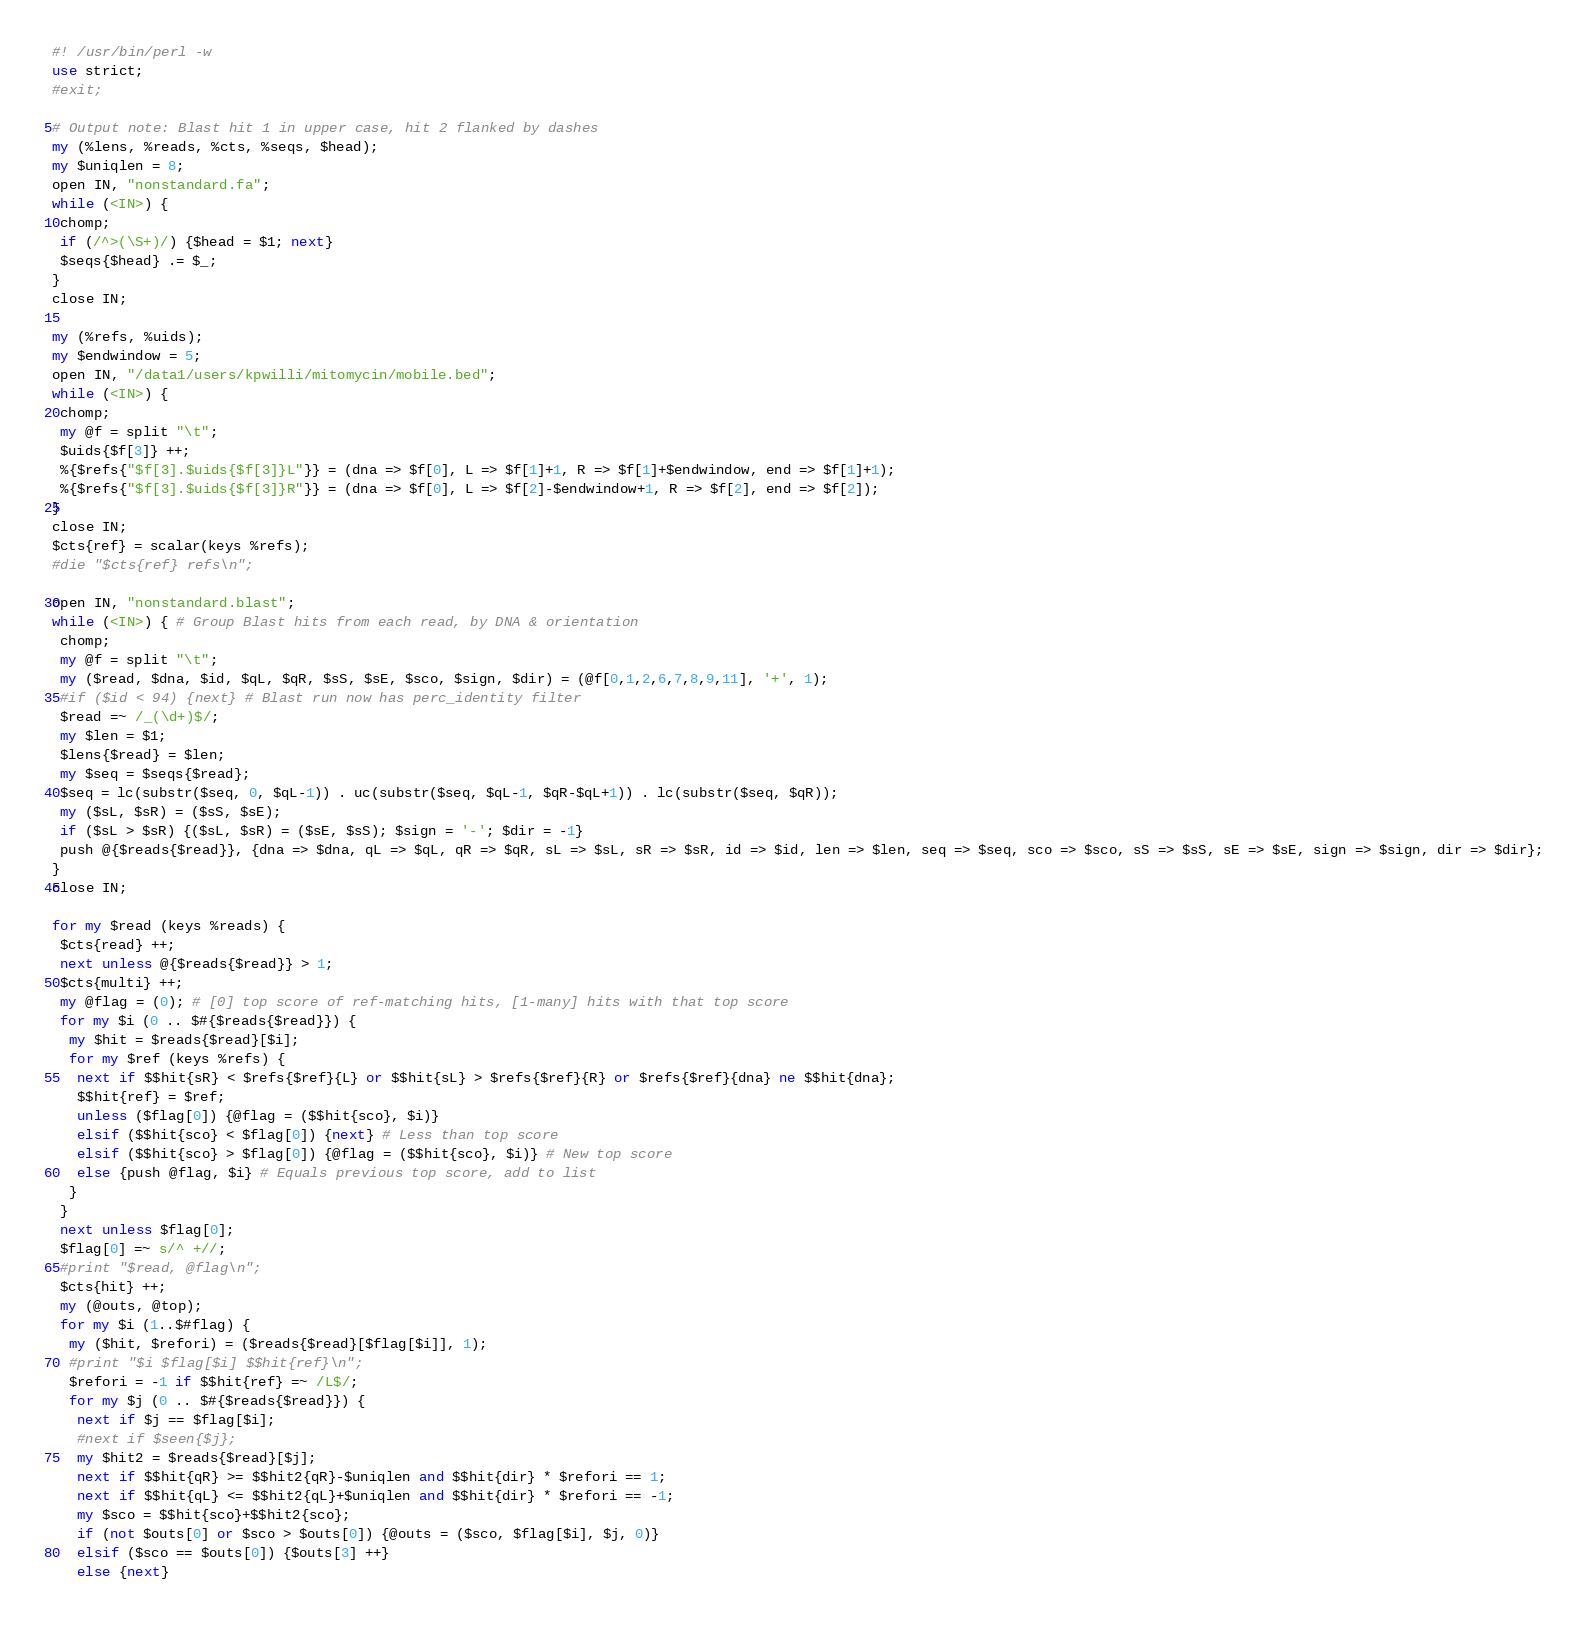Convert code to text. <code><loc_0><loc_0><loc_500><loc_500><_Perl_>#! /usr/bin/perl -w
use strict;
#exit;

# Output note: Blast hit 1 in upper case, hit 2 flanked by dashes
my (%lens, %reads, %cts, %seqs, $head);
my $uniqlen = 8;
open IN, "nonstandard.fa";
while (<IN>) {
 chomp;
 if (/^>(\S+)/) {$head = $1; next}
 $seqs{$head} .= $_;
}
close IN;

my (%refs, %uids);
my $endwindow = 5;
open IN, "/data1/users/kpwilli/mitomycin/mobile.bed";
while (<IN>) {
 chomp;
 my @f = split "\t";
 $uids{$f[3]} ++;
 %{$refs{"$f[3].$uids{$f[3]}L"}} = (dna => $f[0], L => $f[1]+1, R => $f[1]+$endwindow, end => $f[1]+1);
 %{$refs{"$f[3].$uids{$f[3]}R"}} = (dna => $f[0], L => $f[2]-$endwindow+1, R => $f[2], end => $f[2]);
}
close IN;
$cts{ref} = scalar(keys %refs);
#die "$cts{ref} refs\n";

open IN, "nonstandard.blast";
while (<IN>) { # Group Blast hits from each read, by DNA & orientation
 chomp;
 my @f = split "\t";
 my ($read, $dna, $id, $qL, $qR, $sS, $sE, $sco, $sign, $dir) = (@f[0,1,2,6,7,8,9,11], '+', 1);
 #if ($id < 94) {next} # Blast run now has perc_identity filter
 $read =~ /_(\d+)$/; 
 my $len = $1;
 $lens{$read} = $len;
 my $seq = $seqs{$read};
 $seq = lc(substr($seq, 0, $qL-1)) . uc(substr($seq, $qL-1, $qR-$qL+1)) . lc(substr($seq, $qR));
 my ($sL, $sR) = ($sS, $sE);
 if ($sL > $sR) {($sL, $sR) = ($sE, $sS); $sign = '-'; $dir = -1}
 push @{$reads{$read}}, {dna => $dna, qL => $qL, qR => $qR, sL => $sL, sR => $sR, id => $id, len => $len, seq => $seq, sco => $sco, sS => $sS, sE => $sE, sign => $sign, dir => $dir};
}
close IN;

for my $read (keys %reads) {
 $cts{read} ++;
 next unless @{$reads{$read}} > 1;
 $cts{multi} ++;
 my @flag = (0); # [0] top score of ref-matching hits, [1-many] hits with that top score
 for my $i (0 .. $#{$reads{$read}}) {
  my $hit = $reads{$read}[$i];
  for my $ref (keys %refs) {
   next if $$hit{sR} < $refs{$ref}{L} or $$hit{sL} > $refs{$ref}{R} or $refs{$ref}{dna} ne $$hit{dna};
   $$hit{ref} = $ref;
   unless ($flag[0]) {@flag = ($$hit{sco}, $i)}
   elsif ($$hit{sco} < $flag[0]) {next} # Less than top score
   elsif ($$hit{sco} > $flag[0]) {@flag = ($$hit{sco}, $i)} # New top score
   else {push @flag, $i} # Equals previous top score, add to list
  }
 }
 next unless $flag[0];
 $flag[0] =~ s/^ +//;
 #print "$read, @flag\n";
 $cts{hit} ++;
 my (@outs, @top);
 for my $i (1..$#flag) {
  my ($hit, $refori) = ($reads{$read}[$flag[$i]], 1);
  #print "$i $flag[$i] $$hit{ref}\n";
  $refori = -1 if $$hit{ref} =~ /L$/;
  for my $j (0 .. $#{$reads{$read}}) {
   next if $j == $flag[$i];
   #next if $seen{$j};
   my $hit2 = $reads{$read}[$j];
   next if $$hit{qR} >= $$hit2{qR}-$uniqlen and $$hit{dir} * $refori == 1;
   next if $$hit{qL} <= $$hit2{qL}+$uniqlen and $$hit{dir} * $refori == -1;
   my $sco = $$hit{sco}+$$hit2{sco};
   if (not $outs[0] or $sco > $outs[0]) {@outs = ($sco, $flag[$i], $j, 0)}
   elsif ($sco == $outs[0]) {$outs[3] ++}
   else {next}</code> 